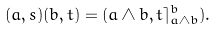Convert formula to latex. <formula><loc_0><loc_0><loc_500><loc_500>( a , s ) ( b , t ) = ( a \wedge b , t \rceil ^ { b } _ { a \wedge b } ) .</formula> 